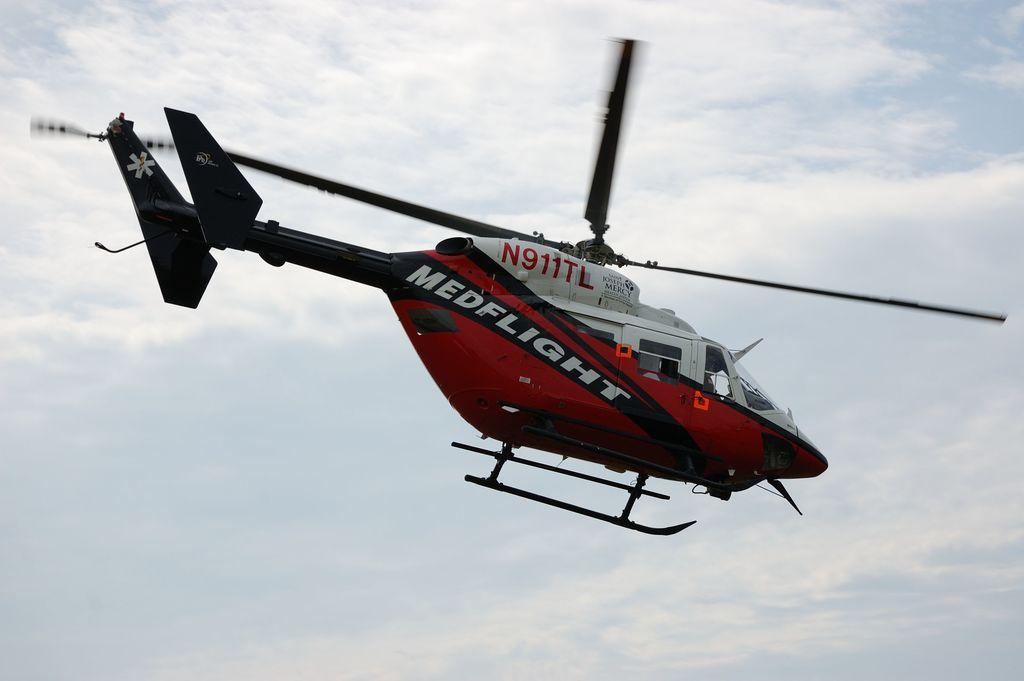<image>
Relay a brief, clear account of the picture shown. MEDFLIGHT helicoptor N911TL flies across a partly cloudy sky. 